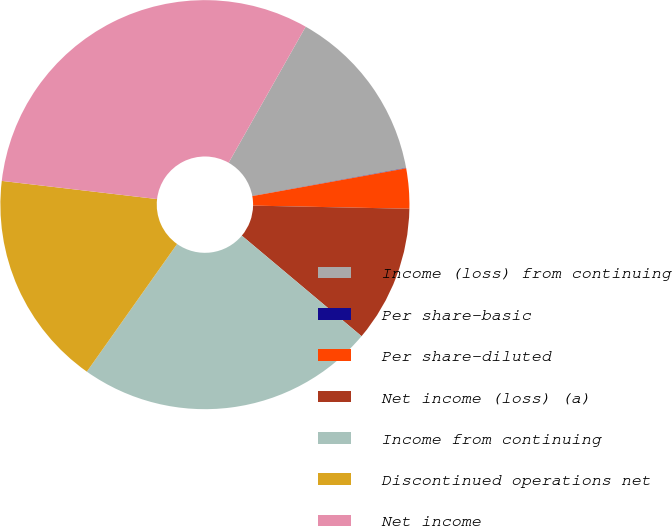Convert chart. <chart><loc_0><loc_0><loc_500><loc_500><pie_chart><fcel>Income (loss) from continuing<fcel>Per share-basic<fcel>Per share-diluted<fcel>Net income (loss) (a)<fcel>Income from continuing<fcel>Discontinued operations net<fcel>Net income<nl><fcel>13.93%<fcel>0.03%<fcel>3.16%<fcel>10.8%<fcel>23.68%<fcel>17.06%<fcel>31.35%<nl></chart> 